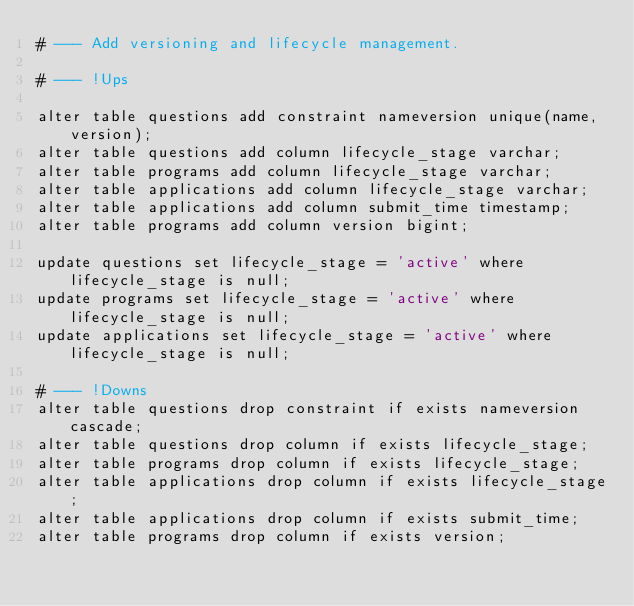Convert code to text. <code><loc_0><loc_0><loc_500><loc_500><_SQL_># --- Add versioning and lifecycle management.

# --- !Ups

alter table questions add constraint nameversion unique(name, version);
alter table questions add column lifecycle_stage varchar;
alter table programs add column lifecycle_stage varchar;
alter table applications add column lifecycle_stage varchar;
alter table applications add column submit_time timestamp;
alter table programs add column version bigint;

update questions set lifecycle_stage = 'active' where lifecycle_stage is null;
update programs set lifecycle_stage = 'active' where lifecycle_stage is null;
update applications set lifecycle_stage = 'active' where lifecycle_stage is null;

# --- !Downs
alter table questions drop constraint if exists nameversion cascade;
alter table questions drop column if exists lifecycle_stage;
alter table programs drop column if exists lifecycle_stage;
alter table applications drop column if exists lifecycle_stage;
alter table applications drop column if exists submit_time;
alter table programs drop column if exists version;</code> 